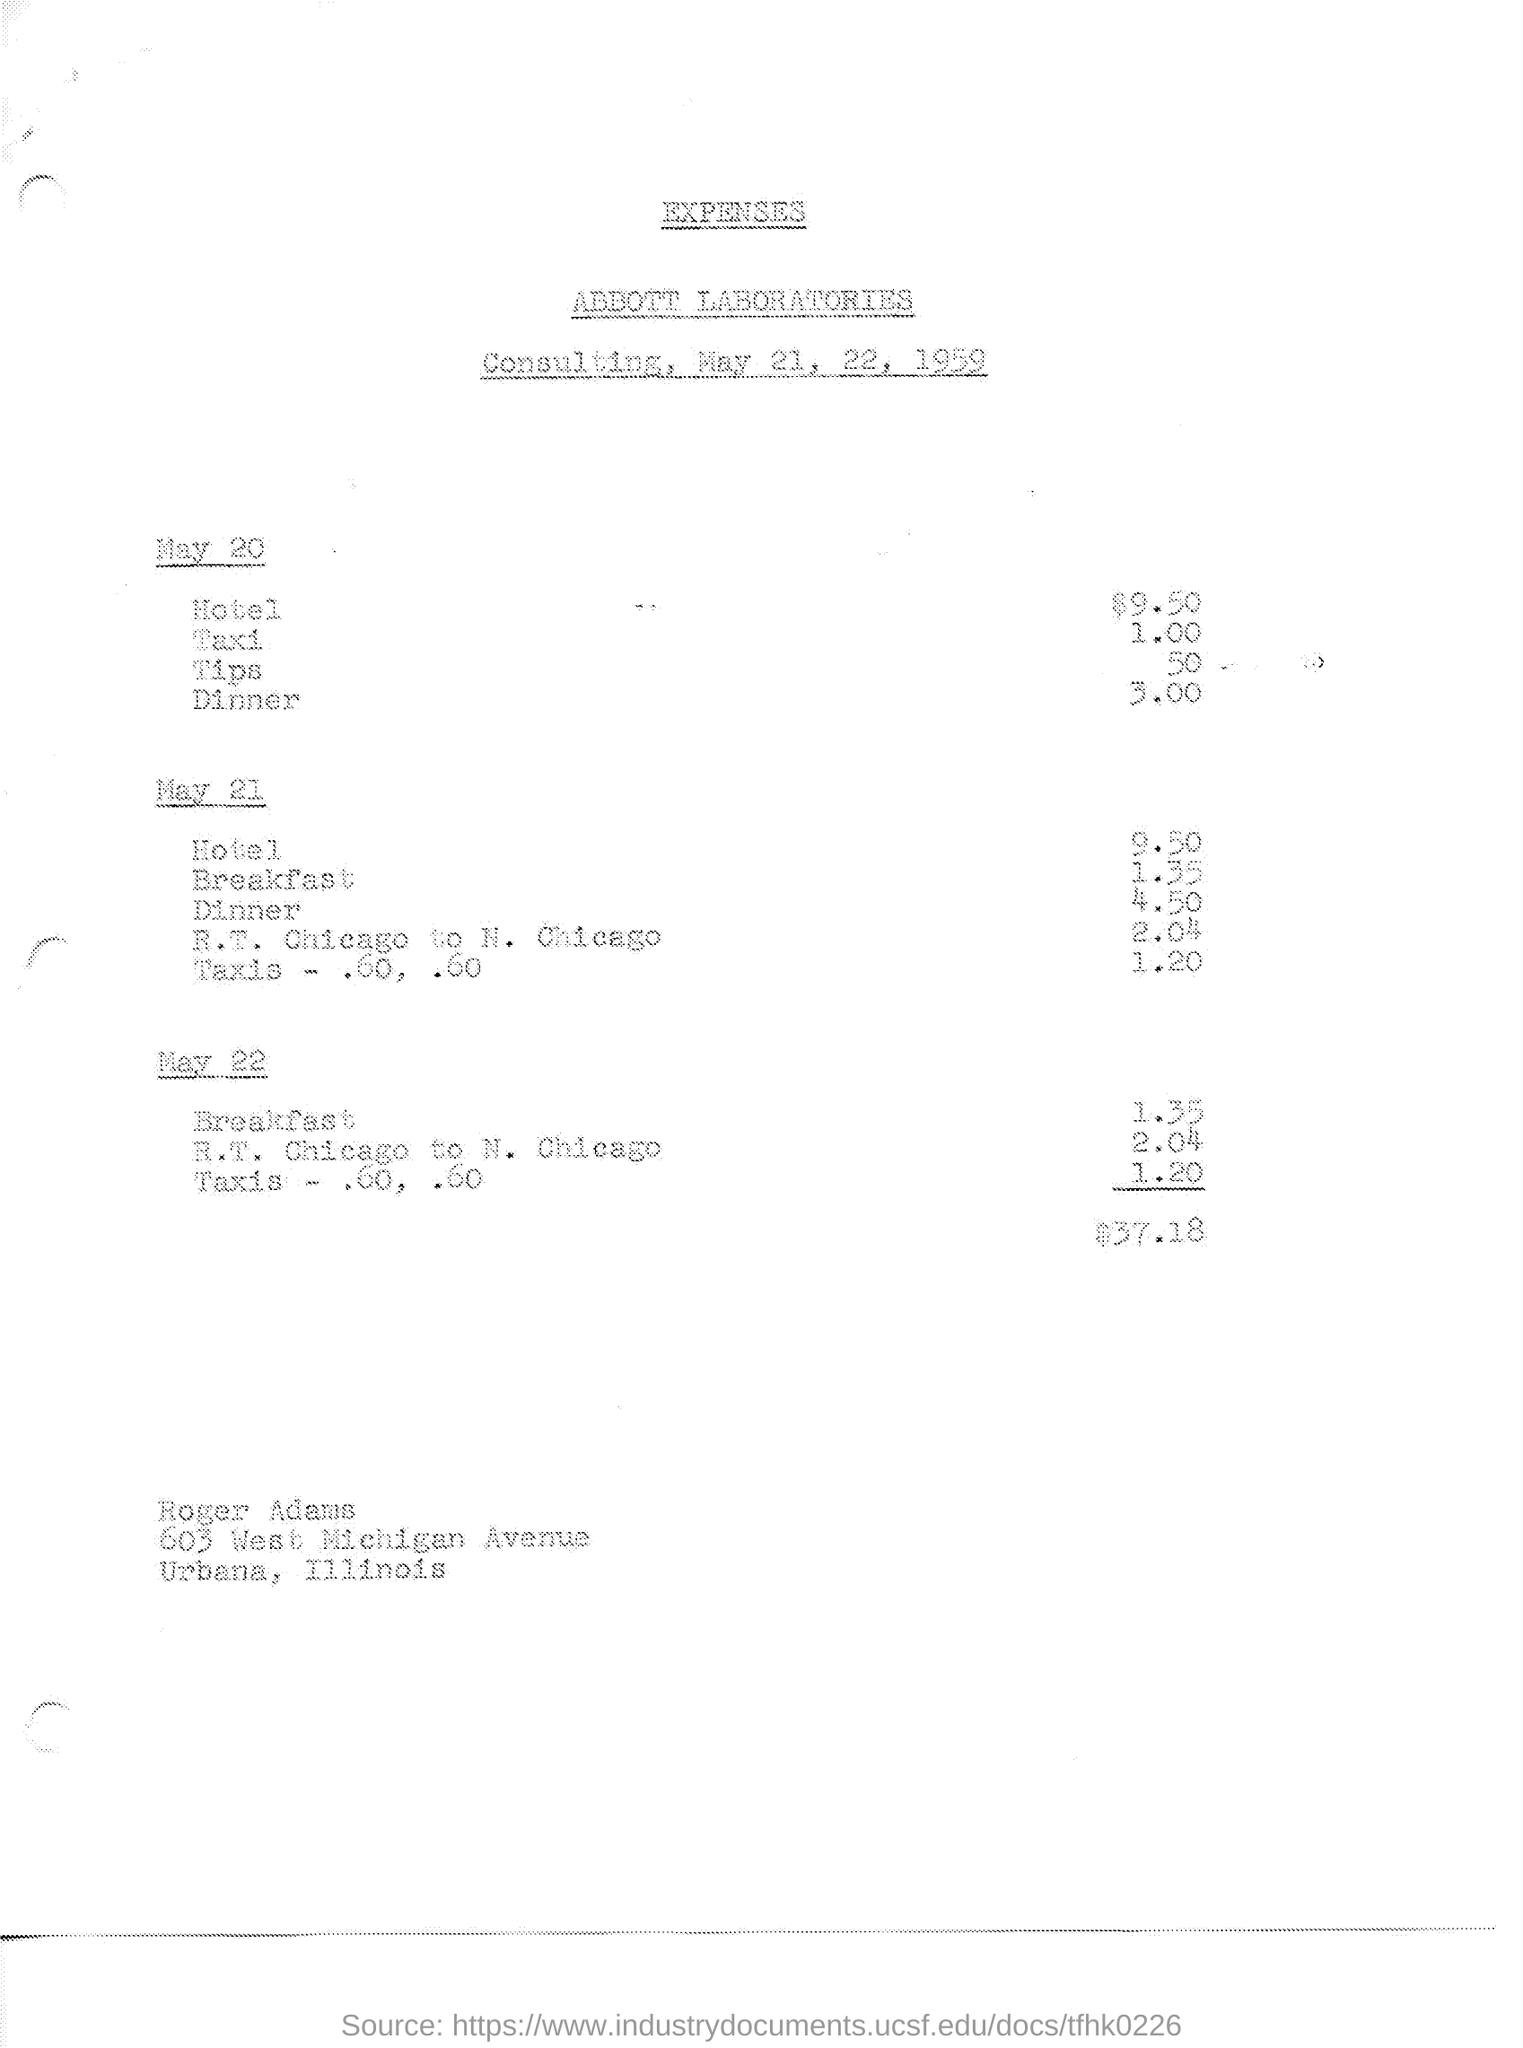Draw attention to some important aspects in this diagram. Abbott Laboratories is mentioned in the text. On May 21 and 22, 1959, a consulting took place. The document title is EXPENSES... 